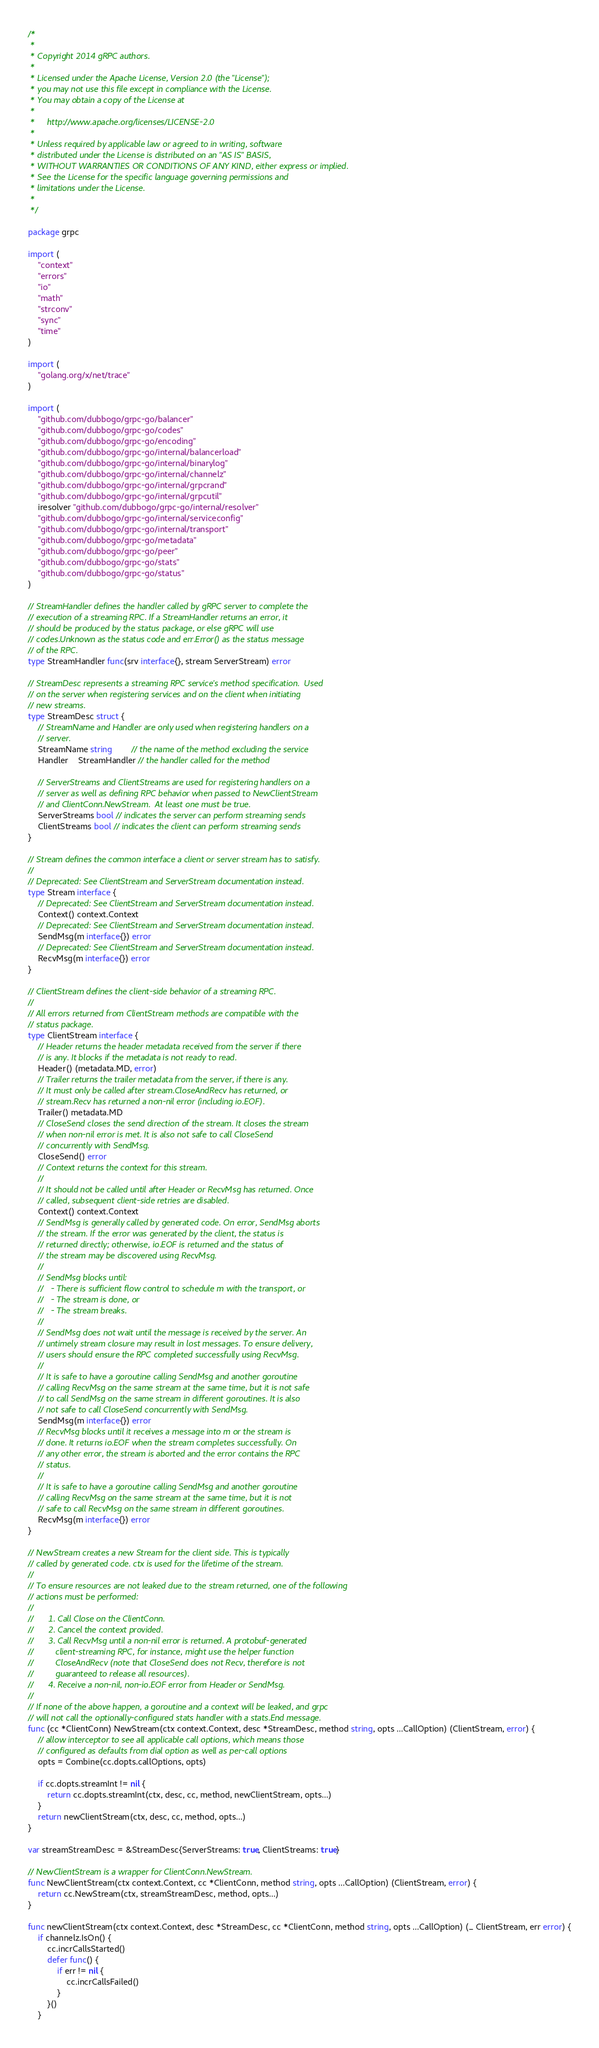<code> <loc_0><loc_0><loc_500><loc_500><_Go_>/*
 *
 * Copyright 2014 gRPC authors.
 *
 * Licensed under the Apache License, Version 2.0 (the "License");
 * you may not use this file except in compliance with the License.
 * You may obtain a copy of the License at
 *
 *     http://www.apache.org/licenses/LICENSE-2.0
 *
 * Unless required by applicable law or agreed to in writing, software
 * distributed under the License is distributed on an "AS IS" BASIS,
 * WITHOUT WARRANTIES OR CONDITIONS OF ANY KIND, either express or implied.
 * See the License for the specific language governing permissions and
 * limitations under the License.
 *
 */

package grpc

import (
	"context"
	"errors"
	"io"
	"math"
	"strconv"
	"sync"
	"time"
)

import (
	"golang.org/x/net/trace"
)

import (
	"github.com/dubbogo/grpc-go/balancer"
	"github.com/dubbogo/grpc-go/codes"
	"github.com/dubbogo/grpc-go/encoding"
	"github.com/dubbogo/grpc-go/internal/balancerload"
	"github.com/dubbogo/grpc-go/internal/binarylog"
	"github.com/dubbogo/grpc-go/internal/channelz"
	"github.com/dubbogo/grpc-go/internal/grpcrand"
	"github.com/dubbogo/grpc-go/internal/grpcutil"
	iresolver "github.com/dubbogo/grpc-go/internal/resolver"
	"github.com/dubbogo/grpc-go/internal/serviceconfig"
	"github.com/dubbogo/grpc-go/internal/transport"
	"github.com/dubbogo/grpc-go/metadata"
	"github.com/dubbogo/grpc-go/peer"
	"github.com/dubbogo/grpc-go/stats"
	"github.com/dubbogo/grpc-go/status"
)

// StreamHandler defines the handler called by gRPC server to complete the
// execution of a streaming RPC. If a StreamHandler returns an error, it
// should be produced by the status package, or else gRPC will use
// codes.Unknown as the status code and err.Error() as the status message
// of the RPC.
type StreamHandler func(srv interface{}, stream ServerStream) error

// StreamDesc represents a streaming RPC service's method specification.  Used
// on the server when registering services and on the client when initiating
// new streams.
type StreamDesc struct {
	// StreamName and Handler are only used when registering handlers on a
	// server.
	StreamName string        // the name of the method excluding the service
	Handler    StreamHandler // the handler called for the method

	// ServerStreams and ClientStreams are used for registering handlers on a
	// server as well as defining RPC behavior when passed to NewClientStream
	// and ClientConn.NewStream.  At least one must be true.
	ServerStreams bool // indicates the server can perform streaming sends
	ClientStreams bool // indicates the client can perform streaming sends
}

// Stream defines the common interface a client or server stream has to satisfy.
//
// Deprecated: See ClientStream and ServerStream documentation instead.
type Stream interface {
	// Deprecated: See ClientStream and ServerStream documentation instead.
	Context() context.Context
	// Deprecated: See ClientStream and ServerStream documentation instead.
	SendMsg(m interface{}) error
	// Deprecated: See ClientStream and ServerStream documentation instead.
	RecvMsg(m interface{}) error
}

// ClientStream defines the client-side behavior of a streaming RPC.
//
// All errors returned from ClientStream methods are compatible with the
// status package.
type ClientStream interface {
	// Header returns the header metadata received from the server if there
	// is any. It blocks if the metadata is not ready to read.
	Header() (metadata.MD, error)
	// Trailer returns the trailer metadata from the server, if there is any.
	// It must only be called after stream.CloseAndRecv has returned, or
	// stream.Recv has returned a non-nil error (including io.EOF).
	Trailer() metadata.MD
	// CloseSend closes the send direction of the stream. It closes the stream
	// when non-nil error is met. It is also not safe to call CloseSend
	// concurrently with SendMsg.
	CloseSend() error
	// Context returns the context for this stream.
	//
	// It should not be called until after Header or RecvMsg has returned. Once
	// called, subsequent client-side retries are disabled.
	Context() context.Context
	// SendMsg is generally called by generated code. On error, SendMsg aborts
	// the stream. If the error was generated by the client, the status is
	// returned directly; otherwise, io.EOF is returned and the status of
	// the stream may be discovered using RecvMsg.
	//
	// SendMsg blocks until:
	//   - There is sufficient flow control to schedule m with the transport, or
	//   - The stream is done, or
	//   - The stream breaks.
	//
	// SendMsg does not wait until the message is received by the server. An
	// untimely stream closure may result in lost messages. To ensure delivery,
	// users should ensure the RPC completed successfully using RecvMsg.
	//
	// It is safe to have a goroutine calling SendMsg and another goroutine
	// calling RecvMsg on the same stream at the same time, but it is not safe
	// to call SendMsg on the same stream in different goroutines. It is also
	// not safe to call CloseSend concurrently with SendMsg.
	SendMsg(m interface{}) error
	// RecvMsg blocks until it receives a message into m or the stream is
	// done. It returns io.EOF when the stream completes successfully. On
	// any other error, the stream is aborted and the error contains the RPC
	// status.
	//
	// It is safe to have a goroutine calling SendMsg and another goroutine
	// calling RecvMsg on the same stream at the same time, but it is not
	// safe to call RecvMsg on the same stream in different goroutines.
	RecvMsg(m interface{}) error
}

// NewStream creates a new Stream for the client side. This is typically
// called by generated code. ctx is used for the lifetime of the stream.
//
// To ensure resources are not leaked due to the stream returned, one of the following
// actions must be performed:
//
//      1. Call Close on the ClientConn.
//      2. Cancel the context provided.
//      3. Call RecvMsg until a non-nil error is returned. A protobuf-generated
//         client-streaming RPC, for instance, might use the helper function
//         CloseAndRecv (note that CloseSend does not Recv, therefore is not
//         guaranteed to release all resources).
//      4. Receive a non-nil, non-io.EOF error from Header or SendMsg.
//
// If none of the above happen, a goroutine and a context will be leaked, and grpc
// will not call the optionally-configured stats handler with a stats.End message.
func (cc *ClientConn) NewStream(ctx context.Context, desc *StreamDesc, method string, opts ...CallOption) (ClientStream, error) {
	// allow interceptor to see all applicable call options, which means those
	// configured as defaults from dial option as well as per-call options
	opts = Combine(cc.dopts.callOptions, opts)

	if cc.dopts.streamInt != nil {
		return cc.dopts.streamInt(ctx, desc, cc, method, newClientStream, opts...)
	}
	return newClientStream(ctx, desc, cc, method, opts...)
}

var streamStreamDesc = &StreamDesc{ServerStreams: true, ClientStreams: true}

// NewClientStream is a wrapper for ClientConn.NewStream.
func NewClientStream(ctx context.Context, cc *ClientConn, method string, opts ...CallOption) (ClientStream, error) {
	return cc.NewStream(ctx, streamStreamDesc, method, opts...)
}

func newClientStream(ctx context.Context, desc *StreamDesc, cc *ClientConn, method string, opts ...CallOption) (_ ClientStream, err error) {
	if channelz.IsOn() {
		cc.incrCallsStarted()
		defer func() {
			if err != nil {
				cc.incrCallsFailed()
			}
		}()
	}</code> 